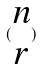<formula> <loc_0><loc_0><loc_500><loc_500>( \begin{matrix} n \\ r \end{matrix} )</formula> 